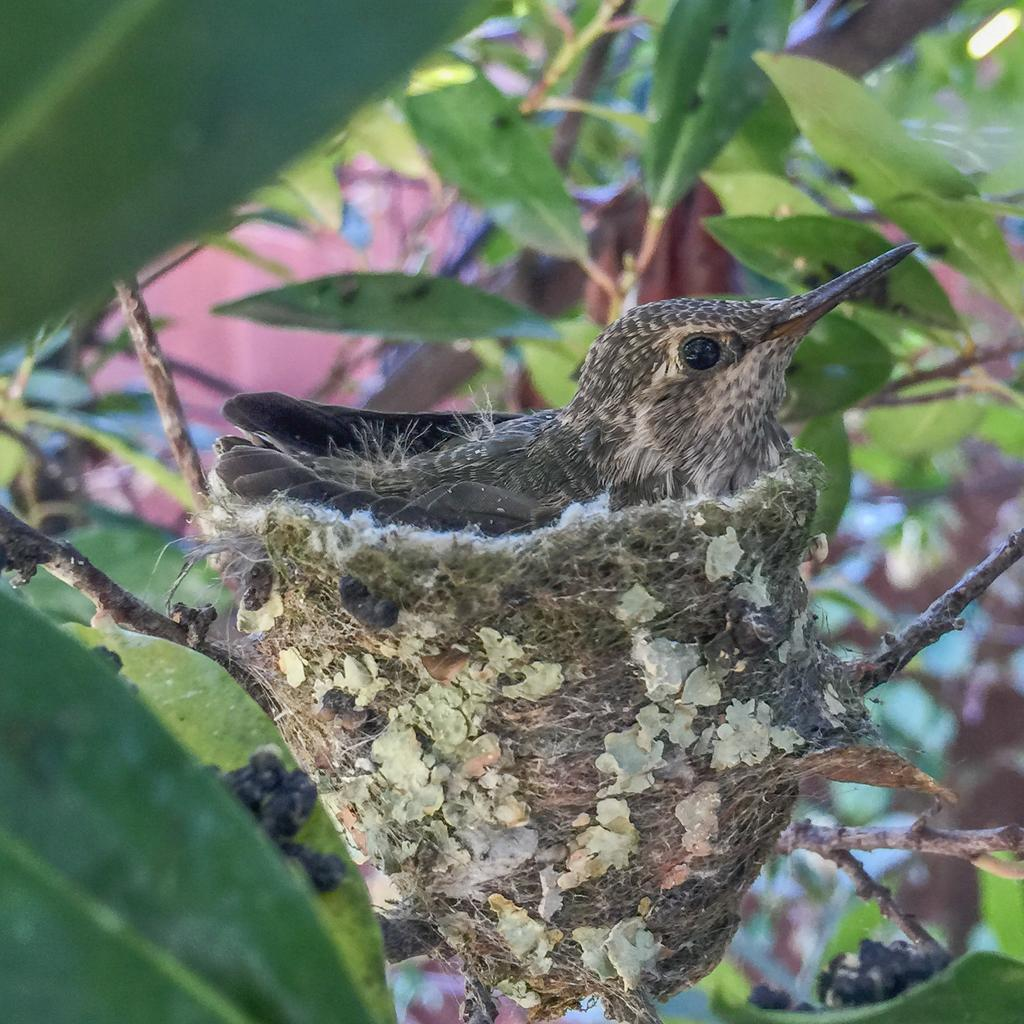What type of animal is in the image? There is a bird in the image. Where is the bird located? The bird is in a nest. What can be seen around the bird? There are branches and leaves around the bird. What type of pain is the bird experiencing in the image? There is no indication in the image that the bird is experiencing any pain. 